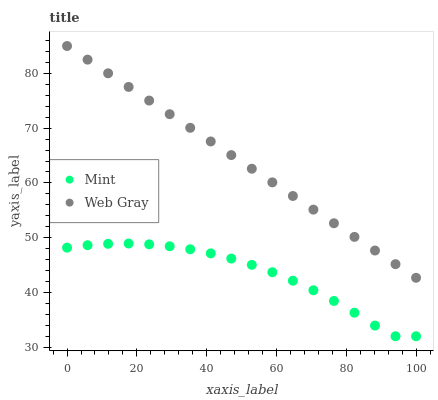Does Mint have the minimum area under the curve?
Answer yes or no. Yes. Does Web Gray have the maximum area under the curve?
Answer yes or no. Yes. Does Mint have the maximum area under the curve?
Answer yes or no. No. Is Web Gray the smoothest?
Answer yes or no. Yes. Is Mint the roughest?
Answer yes or no. Yes. Is Mint the smoothest?
Answer yes or no. No. Does Mint have the lowest value?
Answer yes or no. Yes. Does Web Gray have the highest value?
Answer yes or no. Yes. Does Mint have the highest value?
Answer yes or no. No. Is Mint less than Web Gray?
Answer yes or no. Yes. Is Web Gray greater than Mint?
Answer yes or no. Yes. Does Mint intersect Web Gray?
Answer yes or no. No. 